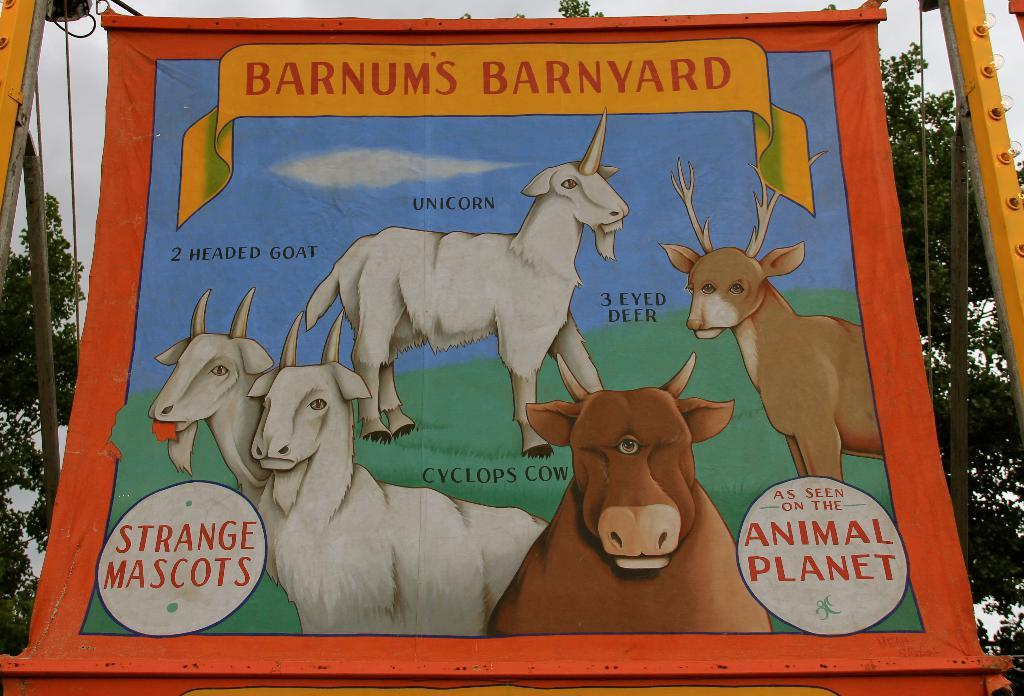What is the main subject in the center of the image? There is a poster in the center of the image. What is depicted on the poster? The poster features animals. What can be seen in the background of the image? There are trees, wires, and the sky visible in the background of the image. How does the system smash the oil in the image? There is no system or oil present in the image; it features a poster with animals and a background with trees, wires, and the sky. 